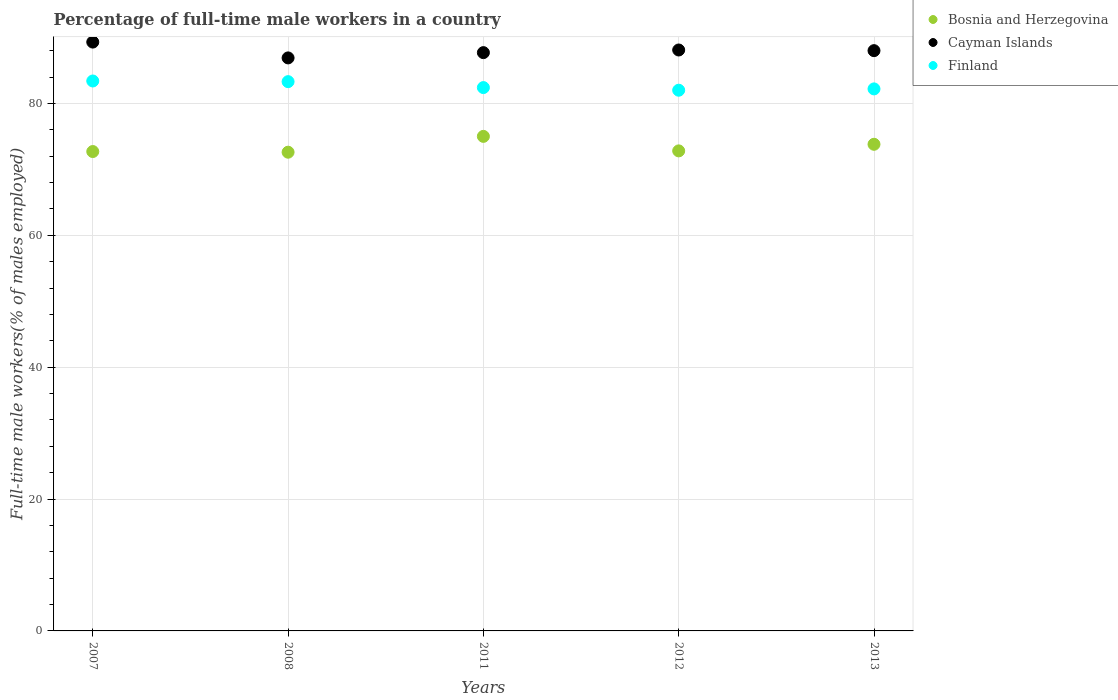How many different coloured dotlines are there?
Provide a succinct answer. 3. What is the percentage of full-time male workers in Finland in 2013?
Your answer should be compact. 82.2. Across all years, what is the minimum percentage of full-time male workers in Bosnia and Herzegovina?
Provide a succinct answer. 72.6. In which year was the percentage of full-time male workers in Cayman Islands minimum?
Your answer should be compact. 2008. What is the total percentage of full-time male workers in Finland in the graph?
Ensure brevity in your answer.  413.3. What is the difference between the percentage of full-time male workers in Cayman Islands in 2012 and that in 2013?
Give a very brief answer. 0.1. What is the difference between the percentage of full-time male workers in Finland in 2011 and the percentage of full-time male workers in Bosnia and Herzegovina in 2007?
Your response must be concise. 9.7. What is the average percentage of full-time male workers in Finland per year?
Provide a short and direct response. 82.66. In the year 2012, what is the difference between the percentage of full-time male workers in Finland and percentage of full-time male workers in Bosnia and Herzegovina?
Make the answer very short. 9.2. In how many years, is the percentage of full-time male workers in Finland greater than 76 %?
Provide a short and direct response. 5. What is the ratio of the percentage of full-time male workers in Bosnia and Herzegovina in 2012 to that in 2013?
Your answer should be compact. 0.99. What is the difference between the highest and the second highest percentage of full-time male workers in Bosnia and Herzegovina?
Offer a very short reply. 1.2. What is the difference between the highest and the lowest percentage of full-time male workers in Bosnia and Herzegovina?
Provide a succinct answer. 2.4. In how many years, is the percentage of full-time male workers in Bosnia and Herzegovina greater than the average percentage of full-time male workers in Bosnia and Herzegovina taken over all years?
Give a very brief answer. 2. Is the sum of the percentage of full-time male workers in Finland in 2012 and 2013 greater than the maximum percentage of full-time male workers in Bosnia and Herzegovina across all years?
Your answer should be compact. Yes. Is the percentage of full-time male workers in Bosnia and Herzegovina strictly greater than the percentage of full-time male workers in Finland over the years?
Your response must be concise. No. Is the percentage of full-time male workers in Cayman Islands strictly less than the percentage of full-time male workers in Bosnia and Herzegovina over the years?
Give a very brief answer. No. What is the difference between two consecutive major ticks on the Y-axis?
Your answer should be compact. 20. Where does the legend appear in the graph?
Your answer should be very brief. Top right. How many legend labels are there?
Provide a short and direct response. 3. What is the title of the graph?
Provide a succinct answer. Percentage of full-time male workers in a country. Does "Switzerland" appear as one of the legend labels in the graph?
Your answer should be compact. No. What is the label or title of the Y-axis?
Provide a short and direct response. Full-time male workers(% of males employed). What is the Full-time male workers(% of males employed) of Bosnia and Herzegovina in 2007?
Your response must be concise. 72.7. What is the Full-time male workers(% of males employed) in Cayman Islands in 2007?
Give a very brief answer. 89.3. What is the Full-time male workers(% of males employed) of Finland in 2007?
Offer a terse response. 83.4. What is the Full-time male workers(% of males employed) in Bosnia and Herzegovina in 2008?
Ensure brevity in your answer.  72.6. What is the Full-time male workers(% of males employed) in Cayman Islands in 2008?
Ensure brevity in your answer.  86.9. What is the Full-time male workers(% of males employed) in Finland in 2008?
Make the answer very short. 83.3. What is the Full-time male workers(% of males employed) in Bosnia and Herzegovina in 2011?
Provide a succinct answer. 75. What is the Full-time male workers(% of males employed) in Cayman Islands in 2011?
Your answer should be very brief. 87.7. What is the Full-time male workers(% of males employed) in Finland in 2011?
Provide a succinct answer. 82.4. What is the Full-time male workers(% of males employed) in Bosnia and Herzegovina in 2012?
Your answer should be compact. 72.8. What is the Full-time male workers(% of males employed) of Cayman Islands in 2012?
Provide a succinct answer. 88.1. What is the Full-time male workers(% of males employed) in Bosnia and Herzegovina in 2013?
Provide a succinct answer. 73.8. What is the Full-time male workers(% of males employed) in Finland in 2013?
Offer a terse response. 82.2. Across all years, what is the maximum Full-time male workers(% of males employed) in Cayman Islands?
Provide a short and direct response. 89.3. Across all years, what is the maximum Full-time male workers(% of males employed) in Finland?
Make the answer very short. 83.4. Across all years, what is the minimum Full-time male workers(% of males employed) of Bosnia and Herzegovina?
Give a very brief answer. 72.6. Across all years, what is the minimum Full-time male workers(% of males employed) of Cayman Islands?
Offer a terse response. 86.9. What is the total Full-time male workers(% of males employed) in Bosnia and Herzegovina in the graph?
Give a very brief answer. 366.9. What is the total Full-time male workers(% of males employed) in Cayman Islands in the graph?
Your answer should be very brief. 440. What is the total Full-time male workers(% of males employed) in Finland in the graph?
Keep it short and to the point. 413.3. What is the difference between the Full-time male workers(% of males employed) of Cayman Islands in 2007 and that in 2008?
Provide a short and direct response. 2.4. What is the difference between the Full-time male workers(% of males employed) of Finland in 2007 and that in 2008?
Make the answer very short. 0.1. What is the difference between the Full-time male workers(% of males employed) of Bosnia and Herzegovina in 2007 and that in 2011?
Offer a very short reply. -2.3. What is the difference between the Full-time male workers(% of males employed) of Cayman Islands in 2007 and that in 2011?
Provide a short and direct response. 1.6. What is the difference between the Full-time male workers(% of males employed) in Finland in 2007 and that in 2011?
Ensure brevity in your answer.  1. What is the difference between the Full-time male workers(% of males employed) of Cayman Islands in 2007 and that in 2012?
Your answer should be compact. 1.2. What is the difference between the Full-time male workers(% of males employed) in Finland in 2007 and that in 2012?
Your response must be concise. 1.4. What is the difference between the Full-time male workers(% of males employed) of Cayman Islands in 2007 and that in 2013?
Your answer should be compact. 1.3. What is the difference between the Full-time male workers(% of males employed) in Bosnia and Herzegovina in 2008 and that in 2011?
Your response must be concise. -2.4. What is the difference between the Full-time male workers(% of males employed) of Cayman Islands in 2008 and that in 2011?
Provide a short and direct response. -0.8. What is the difference between the Full-time male workers(% of males employed) of Cayman Islands in 2008 and that in 2012?
Give a very brief answer. -1.2. What is the difference between the Full-time male workers(% of males employed) in Finland in 2008 and that in 2012?
Your answer should be compact. 1.3. What is the difference between the Full-time male workers(% of males employed) in Cayman Islands in 2008 and that in 2013?
Your response must be concise. -1.1. What is the difference between the Full-time male workers(% of males employed) in Bosnia and Herzegovina in 2011 and that in 2012?
Your answer should be very brief. 2.2. What is the difference between the Full-time male workers(% of males employed) of Cayman Islands in 2011 and that in 2012?
Offer a very short reply. -0.4. What is the difference between the Full-time male workers(% of males employed) of Bosnia and Herzegovina in 2011 and that in 2013?
Provide a succinct answer. 1.2. What is the difference between the Full-time male workers(% of males employed) in Cayman Islands in 2011 and that in 2013?
Your response must be concise. -0.3. What is the difference between the Full-time male workers(% of males employed) in Finland in 2011 and that in 2013?
Give a very brief answer. 0.2. What is the difference between the Full-time male workers(% of males employed) of Cayman Islands in 2012 and that in 2013?
Your answer should be compact. 0.1. What is the difference between the Full-time male workers(% of males employed) in Bosnia and Herzegovina in 2007 and the Full-time male workers(% of males employed) in Cayman Islands in 2008?
Make the answer very short. -14.2. What is the difference between the Full-time male workers(% of males employed) of Bosnia and Herzegovina in 2007 and the Full-time male workers(% of males employed) of Cayman Islands in 2011?
Offer a terse response. -15. What is the difference between the Full-time male workers(% of males employed) in Cayman Islands in 2007 and the Full-time male workers(% of males employed) in Finland in 2011?
Keep it short and to the point. 6.9. What is the difference between the Full-time male workers(% of males employed) of Bosnia and Herzegovina in 2007 and the Full-time male workers(% of males employed) of Cayman Islands in 2012?
Your response must be concise. -15.4. What is the difference between the Full-time male workers(% of males employed) of Cayman Islands in 2007 and the Full-time male workers(% of males employed) of Finland in 2012?
Make the answer very short. 7.3. What is the difference between the Full-time male workers(% of males employed) in Bosnia and Herzegovina in 2007 and the Full-time male workers(% of males employed) in Cayman Islands in 2013?
Provide a short and direct response. -15.3. What is the difference between the Full-time male workers(% of males employed) of Cayman Islands in 2007 and the Full-time male workers(% of males employed) of Finland in 2013?
Provide a short and direct response. 7.1. What is the difference between the Full-time male workers(% of males employed) of Bosnia and Herzegovina in 2008 and the Full-time male workers(% of males employed) of Cayman Islands in 2011?
Give a very brief answer. -15.1. What is the difference between the Full-time male workers(% of males employed) in Bosnia and Herzegovina in 2008 and the Full-time male workers(% of males employed) in Finland in 2011?
Your response must be concise. -9.8. What is the difference between the Full-time male workers(% of males employed) of Cayman Islands in 2008 and the Full-time male workers(% of males employed) of Finland in 2011?
Ensure brevity in your answer.  4.5. What is the difference between the Full-time male workers(% of males employed) of Bosnia and Herzegovina in 2008 and the Full-time male workers(% of males employed) of Cayman Islands in 2012?
Your response must be concise. -15.5. What is the difference between the Full-time male workers(% of males employed) of Bosnia and Herzegovina in 2008 and the Full-time male workers(% of males employed) of Finland in 2012?
Ensure brevity in your answer.  -9.4. What is the difference between the Full-time male workers(% of males employed) in Bosnia and Herzegovina in 2008 and the Full-time male workers(% of males employed) in Cayman Islands in 2013?
Offer a terse response. -15.4. What is the difference between the Full-time male workers(% of males employed) of Cayman Islands in 2008 and the Full-time male workers(% of males employed) of Finland in 2013?
Offer a terse response. 4.7. What is the difference between the Full-time male workers(% of males employed) in Bosnia and Herzegovina in 2011 and the Full-time male workers(% of males employed) in Cayman Islands in 2012?
Give a very brief answer. -13.1. What is the difference between the Full-time male workers(% of males employed) in Cayman Islands in 2011 and the Full-time male workers(% of males employed) in Finland in 2012?
Offer a very short reply. 5.7. What is the difference between the Full-time male workers(% of males employed) in Bosnia and Herzegovina in 2011 and the Full-time male workers(% of males employed) in Cayman Islands in 2013?
Your answer should be very brief. -13. What is the difference between the Full-time male workers(% of males employed) of Bosnia and Herzegovina in 2012 and the Full-time male workers(% of males employed) of Cayman Islands in 2013?
Keep it short and to the point. -15.2. What is the average Full-time male workers(% of males employed) of Bosnia and Herzegovina per year?
Offer a terse response. 73.38. What is the average Full-time male workers(% of males employed) of Cayman Islands per year?
Provide a succinct answer. 88. What is the average Full-time male workers(% of males employed) in Finland per year?
Offer a very short reply. 82.66. In the year 2007, what is the difference between the Full-time male workers(% of males employed) of Bosnia and Herzegovina and Full-time male workers(% of males employed) of Cayman Islands?
Ensure brevity in your answer.  -16.6. In the year 2008, what is the difference between the Full-time male workers(% of males employed) in Bosnia and Herzegovina and Full-time male workers(% of males employed) in Cayman Islands?
Offer a very short reply. -14.3. In the year 2008, what is the difference between the Full-time male workers(% of males employed) of Bosnia and Herzegovina and Full-time male workers(% of males employed) of Finland?
Ensure brevity in your answer.  -10.7. In the year 2008, what is the difference between the Full-time male workers(% of males employed) in Cayman Islands and Full-time male workers(% of males employed) in Finland?
Give a very brief answer. 3.6. In the year 2011, what is the difference between the Full-time male workers(% of males employed) of Bosnia and Herzegovina and Full-time male workers(% of males employed) of Cayman Islands?
Provide a succinct answer. -12.7. In the year 2011, what is the difference between the Full-time male workers(% of males employed) in Bosnia and Herzegovina and Full-time male workers(% of males employed) in Finland?
Your answer should be very brief. -7.4. In the year 2012, what is the difference between the Full-time male workers(% of males employed) of Bosnia and Herzegovina and Full-time male workers(% of males employed) of Cayman Islands?
Your answer should be compact. -15.3. In the year 2012, what is the difference between the Full-time male workers(% of males employed) of Bosnia and Herzegovina and Full-time male workers(% of males employed) of Finland?
Your answer should be very brief. -9.2. In the year 2012, what is the difference between the Full-time male workers(% of males employed) in Cayman Islands and Full-time male workers(% of males employed) in Finland?
Provide a succinct answer. 6.1. In the year 2013, what is the difference between the Full-time male workers(% of males employed) of Bosnia and Herzegovina and Full-time male workers(% of males employed) of Cayman Islands?
Make the answer very short. -14.2. What is the ratio of the Full-time male workers(% of males employed) in Cayman Islands in 2007 to that in 2008?
Your answer should be compact. 1.03. What is the ratio of the Full-time male workers(% of males employed) in Finland in 2007 to that in 2008?
Your answer should be very brief. 1. What is the ratio of the Full-time male workers(% of males employed) of Bosnia and Herzegovina in 2007 to that in 2011?
Make the answer very short. 0.97. What is the ratio of the Full-time male workers(% of males employed) in Cayman Islands in 2007 to that in 2011?
Offer a terse response. 1.02. What is the ratio of the Full-time male workers(% of males employed) of Finland in 2007 to that in 2011?
Ensure brevity in your answer.  1.01. What is the ratio of the Full-time male workers(% of males employed) of Cayman Islands in 2007 to that in 2012?
Give a very brief answer. 1.01. What is the ratio of the Full-time male workers(% of males employed) of Finland in 2007 to that in 2012?
Make the answer very short. 1.02. What is the ratio of the Full-time male workers(% of males employed) of Bosnia and Herzegovina in 2007 to that in 2013?
Your answer should be very brief. 0.99. What is the ratio of the Full-time male workers(% of males employed) of Cayman Islands in 2007 to that in 2013?
Provide a succinct answer. 1.01. What is the ratio of the Full-time male workers(% of males employed) of Finland in 2007 to that in 2013?
Your answer should be very brief. 1.01. What is the ratio of the Full-time male workers(% of males employed) in Bosnia and Herzegovina in 2008 to that in 2011?
Your answer should be compact. 0.97. What is the ratio of the Full-time male workers(% of males employed) of Cayman Islands in 2008 to that in 2011?
Offer a terse response. 0.99. What is the ratio of the Full-time male workers(% of males employed) of Finland in 2008 to that in 2011?
Offer a very short reply. 1.01. What is the ratio of the Full-time male workers(% of males employed) of Cayman Islands in 2008 to that in 2012?
Your answer should be compact. 0.99. What is the ratio of the Full-time male workers(% of males employed) of Finland in 2008 to that in 2012?
Keep it short and to the point. 1.02. What is the ratio of the Full-time male workers(% of males employed) in Bosnia and Herzegovina in 2008 to that in 2013?
Offer a terse response. 0.98. What is the ratio of the Full-time male workers(% of males employed) of Cayman Islands in 2008 to that in 2013?
Your answer should be very brief. 0.99. What is the ratio of the Full-time male workers(% of males employed) in Finland in 2008 to that in 2013?
Your response must be concise. 1.01. What is the ratio of the Full-time male workers(% of males employed) of Bosnia and Herzegovina in 2011 to that in 2012?
Your response must be concise. 1.03. What is the ratio of the Full-time male workers(% of males employed) in Cayman Islands in 2011 to that in 2012?
Your response must be concise. 1. What is the ratio of the Full-time male workers(% of males employed) in Bosnia and Herzegovina in 2011 to that in 2013?
Your answer should be very brief. 1.02. What is the ratio of the Full-time male workers(% of males employed) in Cayman Islands in 2011 to that in 2013?
Keep it short and to the point. 1. What is the ratio of the Full-time male workers(% of males employed) of Bosnia and Herzegovina in 2012 to that in 2013?
Your response must be concise. 0.99. What is the ratio of the Full-time male workers(% of males employed) in Finland in 2012 to that in 2013?
Provide a short and direct response. 1. What is the difference between the highest and the second highest Full-time male workers(% of males employed) in Cayman Islands?
Offer a very short reply. 1.2. What is the difference between the highest and the second highest Full-time male workers(% of males employed) of Finland?
Give a very brief answer. 0.1. What is the difference between the highest and the lowest Full-time male workers(% of males employed) of Finland?
Your answer should be compact. 1.4. 